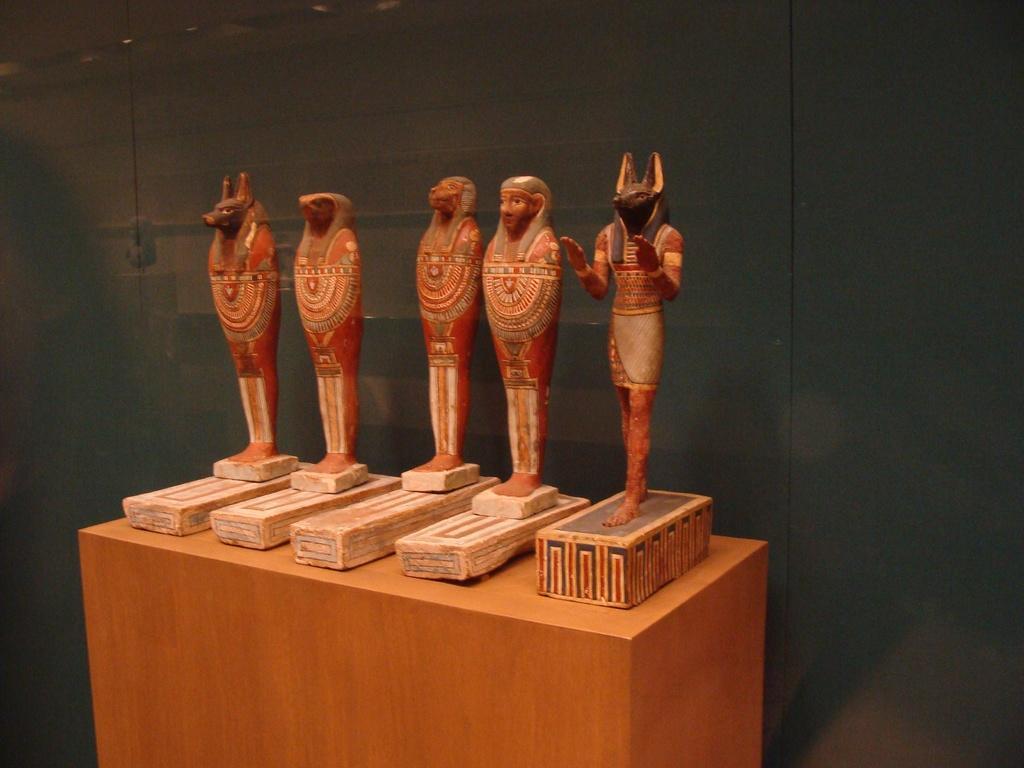Can you describe this image briefly? In the image in the center there is a table. On the table, we can see boxes. On the boxes, we can see the sculptures. In the background there is a wall. 